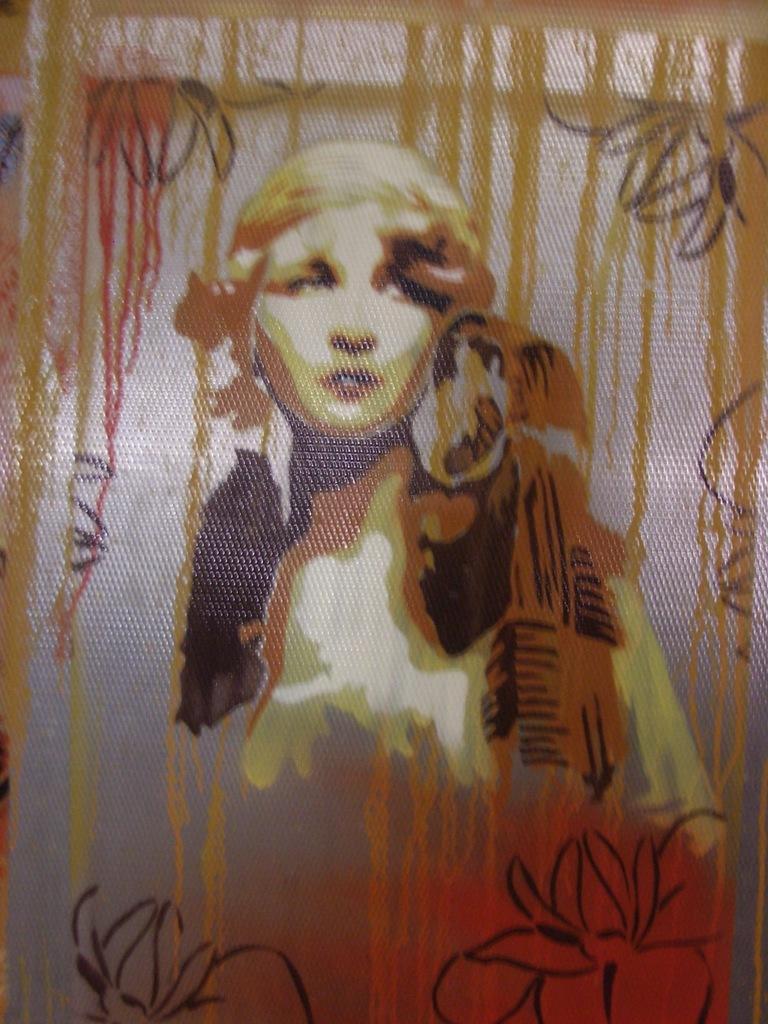Could you give a brief overview of what you see in this image? We can see painting of a person on a glass. 